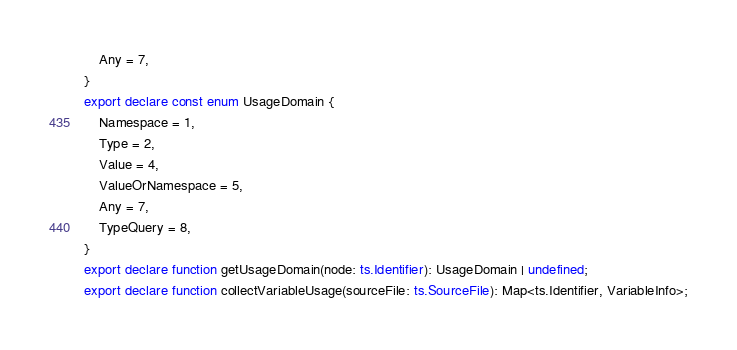Convert code to text. <code><loc_0><loc_0><loc_500><loc_500><_TypeScript_>    Any = 7,
}
export declare const enum UsageDomain {
    Namespace = 1,
    Type = 2,
    Value = 4,
    ValueOrNamespace = 5,
    Any = 7,
    TypeQuery = 8,
}
export declare function getUsageDomain(node: ts.Identifier): UsageDomain | undefined;
export declare function collectVariableUsage(sourceFile: ts.SourceFile): Map<ts.Identifier, VariableInfo>;
</code> 